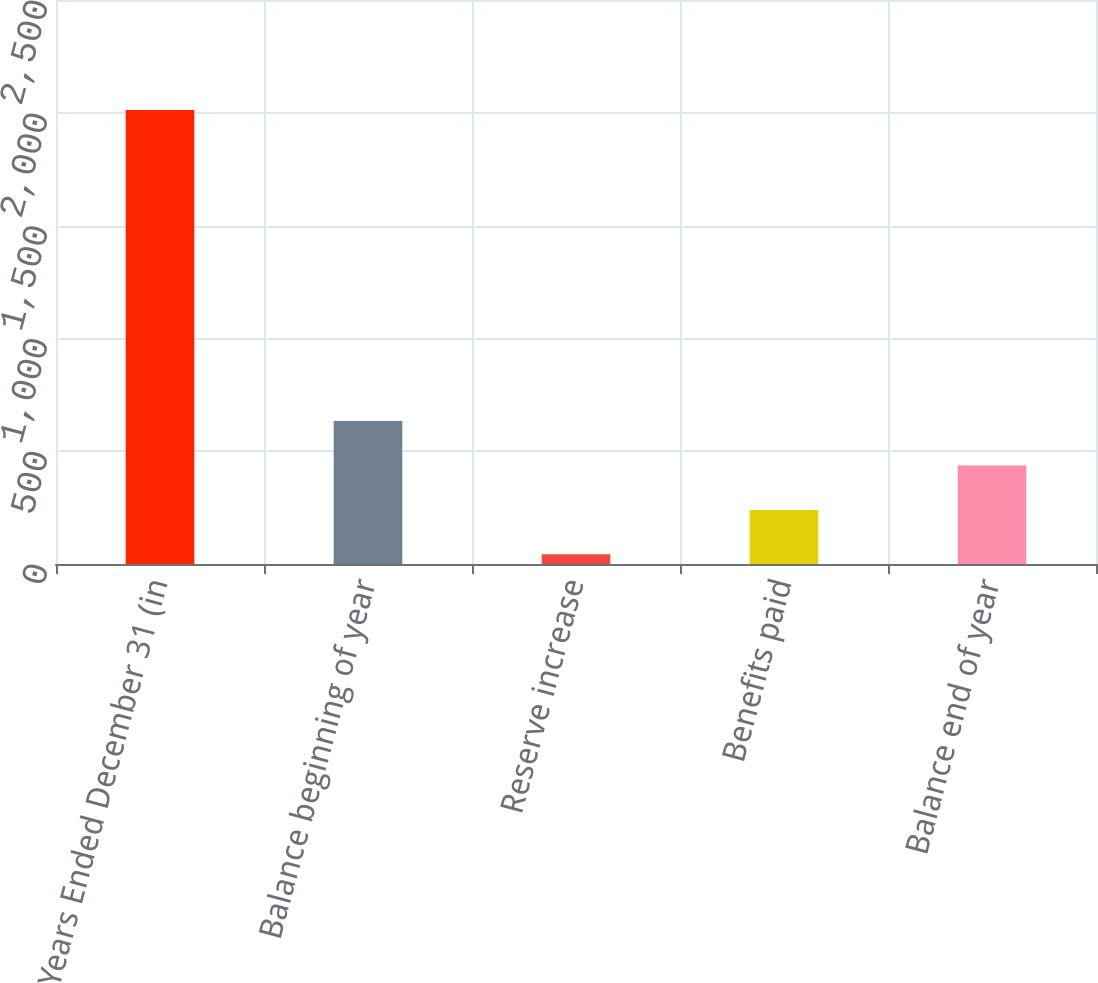<chart> <loc_0><loc_0><loc_500><loc_500><bar_chart><fcel>Years Ended December 31 (in<fcel>Balance beginning of year<fcel>Reserve increase<fcel>Benefits paid<fcel>Balance end of year<nl><fcel>2012<fcel>633.7<fcel>43<fcel>239.9<fcel>436.8<nl></chart> 